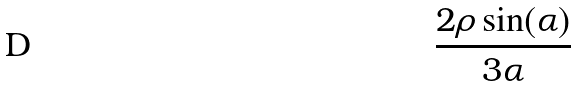Convert formula to latex. <formula><loc_0><loc_0><loc_500><loc_500>\frac { 2 \rho \sin ( \alpha ) } { 3 \alpha }</formula> 